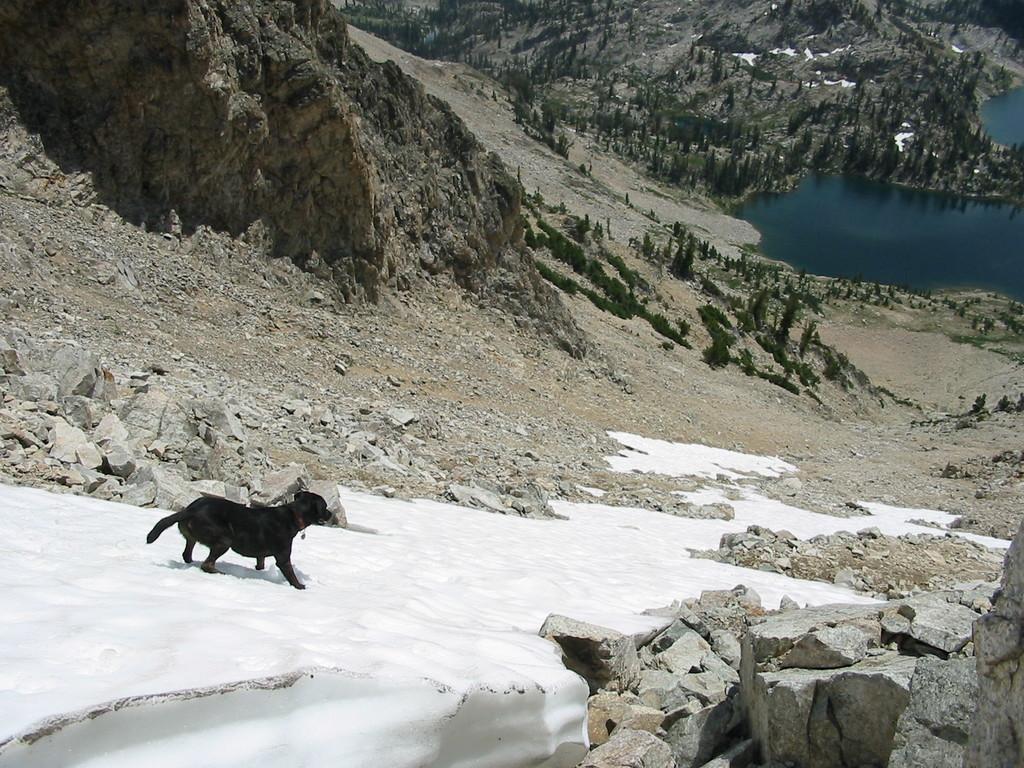In one or two sentences, can you explain what this image depicts? In this image, on the left there is a dog. In the middle there are stones, trees, water, falls, iceland. 